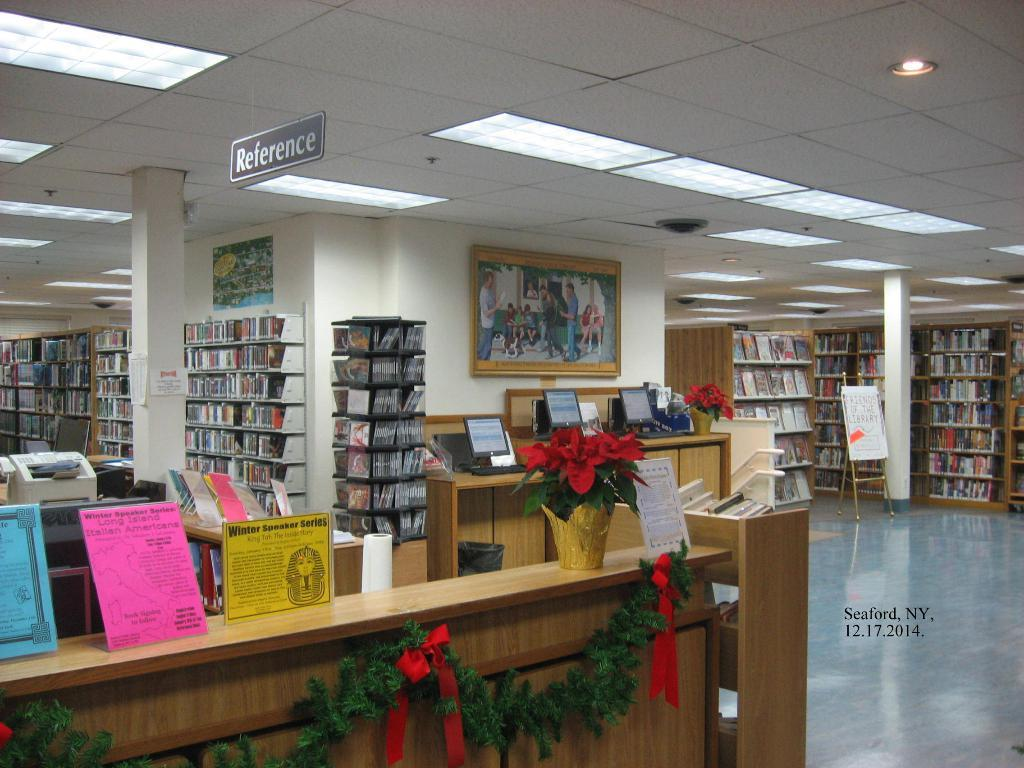<image>
Offer a succinct explanation of the picture presented. a library in Seaford NY taken on 12.17.2014 